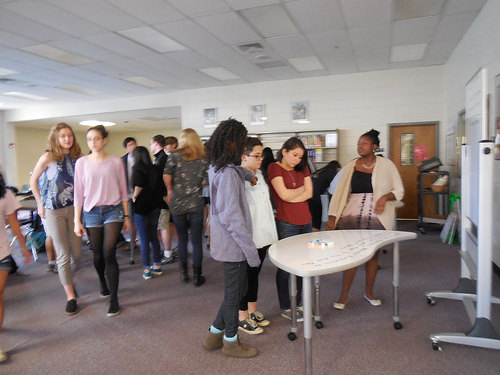<image>
Can you confirm if the table is behind the girl? No. The table is not behind the girl. From this viewpoint, the table appears to be positioned elsewhere in the scene. 